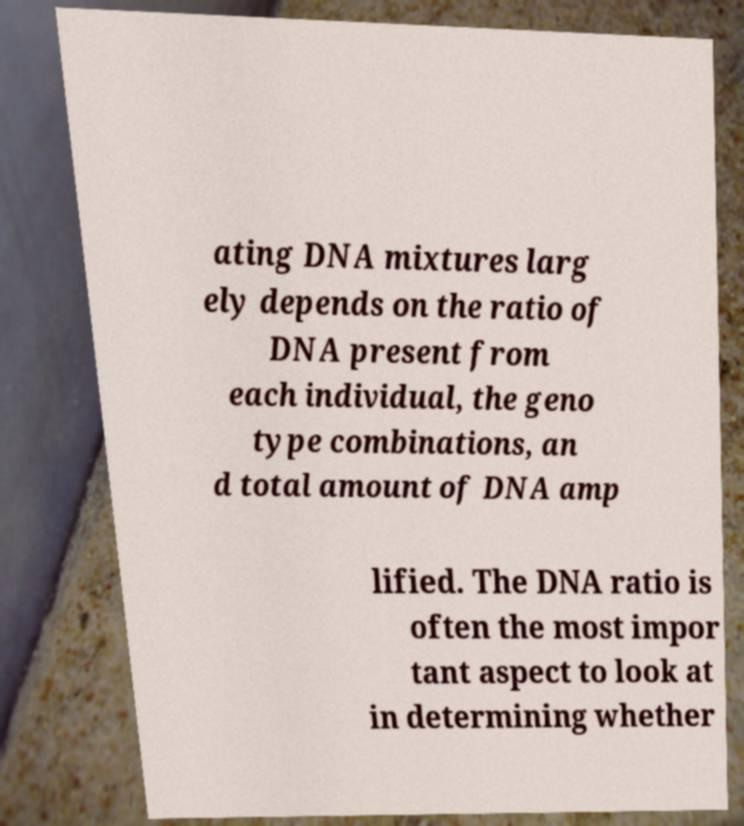What messages or text are displayed in this image? I need them in a readable, typed format. ating DNA mixtures larg ely depends on the ratio of DNA present from each individual, the geno type combinations, an d total amount of DNA amp lified. The DNA ratio is often the most impor tant aspect to look at in determining whether 